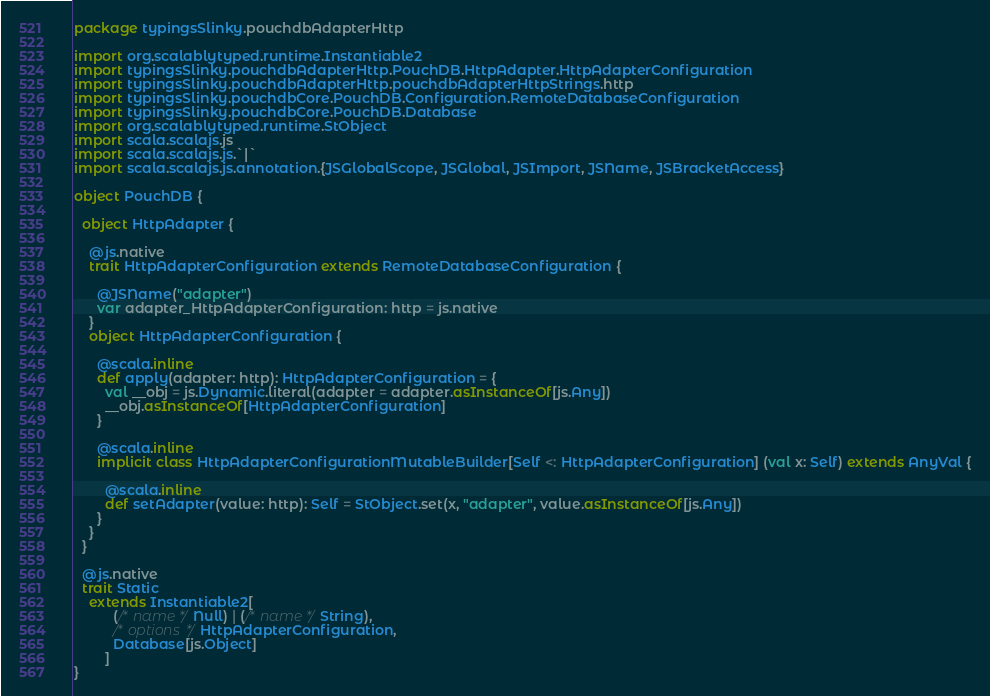Convert code to text. <code><loc_0><loc_0><loc_500><loc_500><_Scala_>package typingsSlinky.pouchdbAdapterHttp

import org.scalablytyped.runtime.Instantiable2
import typingsSlinky.pouchdbAdapterHttp.PouchDB.HttpAdapter.HttpAdapterConfiguration
import typingsSlinky.pouchdbAdapterHttp.pouchdbAdapterHttpStrings.http
import typingsSlinky.pouchdbCore.PouchDB.Configuration.RemoteDatabaseConfiguration
import typingsSlinky.pouchdbCore.PouchDB.Database
import org.scalablytyped.runtime.StObject
import scala.scalajs.js
import scala.scalajs.js.`|`
import scala.scalajs.js.annotation.{JSGlobalScope, JSGlobal, JSImport, JSName, JSBracketAccess}

object PouchDB {
  
  object HttpAdapter {
    
    @js.native
    trait HttpAdapterConfiguration extends RemoteDatabaseConfiguration {
      
      @JSName("adapter")
      var adapter_HttpAdapterConfiguration: http = js.native
    }
    object HttpAdapterConfiguration {
      
      @scala.inline
      def apply(adapter: http): HttpAdapterConfiguration = {
        val __obj = js.Dynamic.literal(adapter = adapter.asInstanceOf[js.Any])
        __obj.asInstanceOf[HttpAdapterConfiguration]
      }
      
      @scala.inline
      implicit class HttpAdapterConfigurationMutableBuilder[Self <: HttpAdapterConfiguration] (val x: Self) extends AnyVal {
        
        @scala.inline
        def setAdapter(value: http): Self = StObject.set(x, "adapter", value.asInstanceOf[js.Any])
      }
    }
  }
  
  @js.native
  trait Static
    extends Instantiable2[
          (/* name */ Null) | (/* name */ String), 
          /* options */ HttpAdapterConfiguration, 
          Database[js.Object]
        ]
}
</code> 